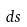Convert formula to latex. <formula><loc_0><loc_0><loc_500><loc_500>d s</formula> 